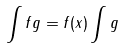Convert formula to latex. <formula><loc_0><loc_0><loc_500><loc_500>\int f g = f ( x ) \int g</formula> 